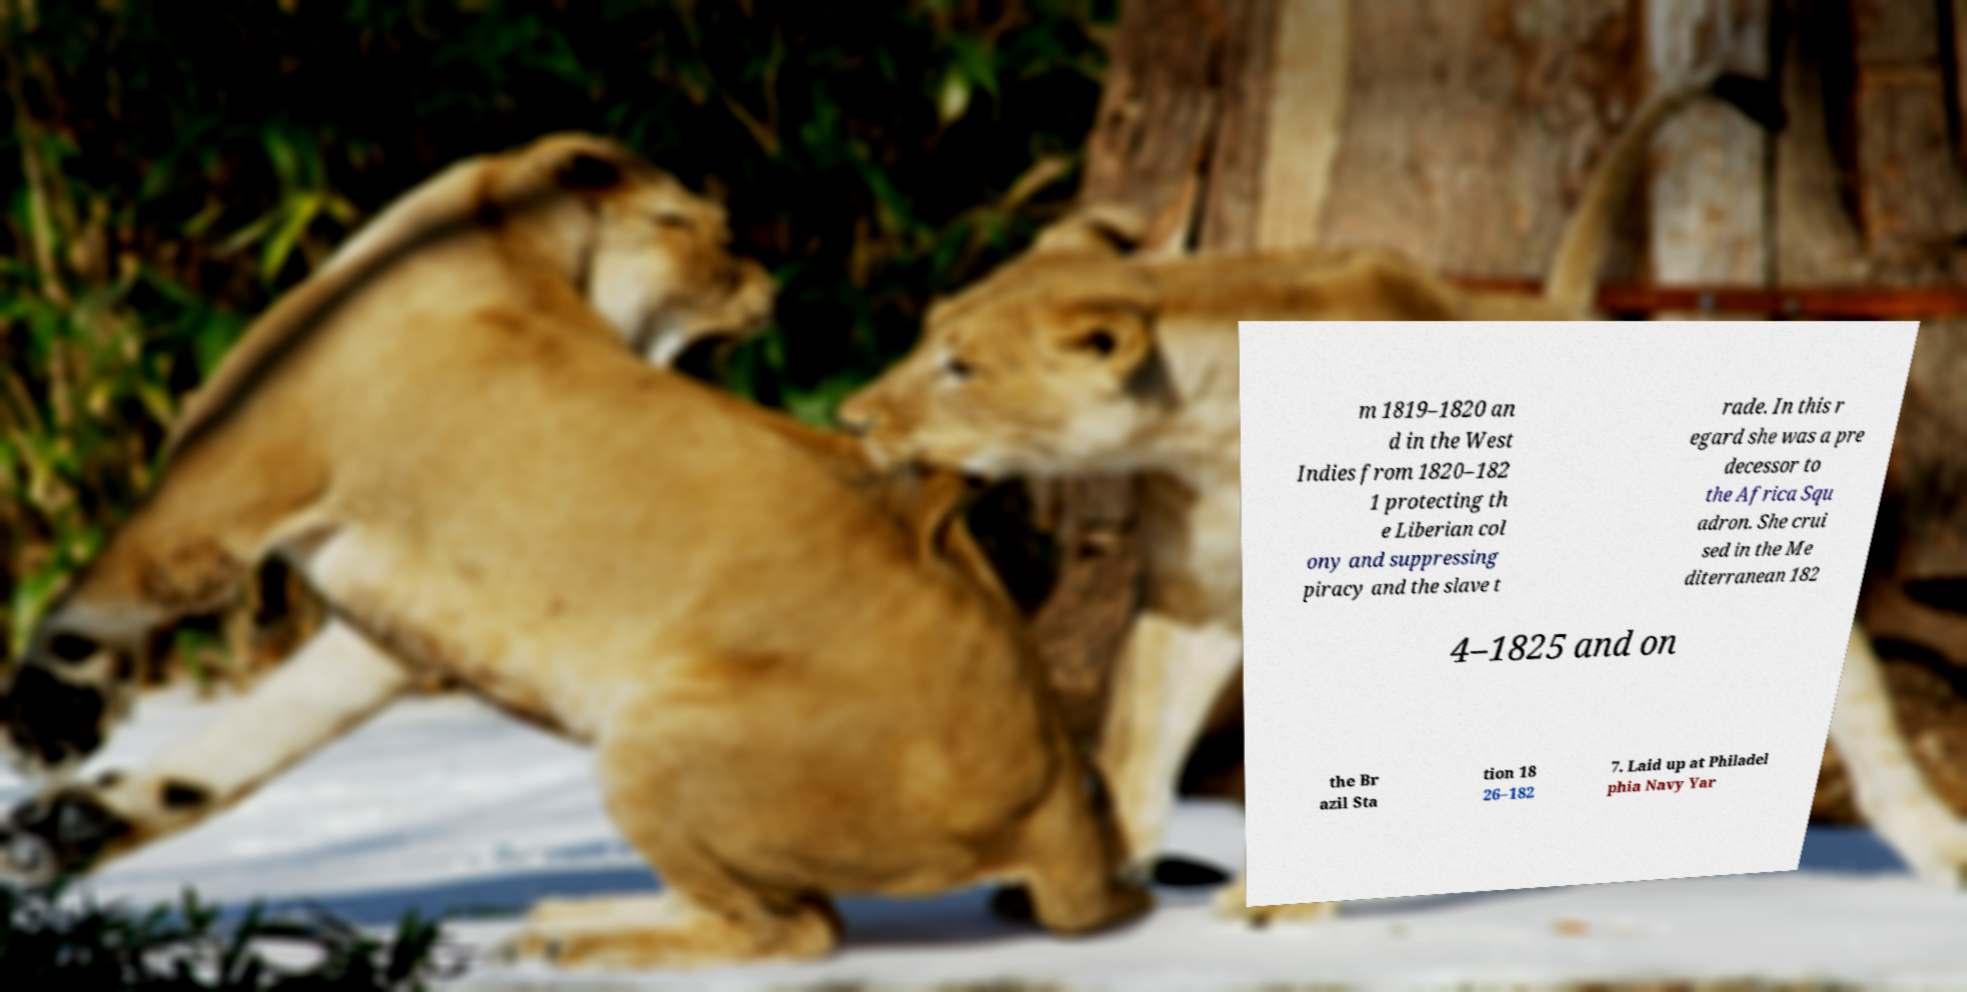Could you assist in decoding the text presented in this image and type it out clearly? m 1819–1820 an d in the West Indies from 1820–182 1 protecting th e Liberian col ony and suppressing piracy and the slave t rade. In this r egard she was a pre decessor to the Africa Squ adron. She crui sed in the Me diterranean 182 4–1825 and on the Br azil Sta tion 18 26–182 7. Laid up at Philadel phia Navy Yar 